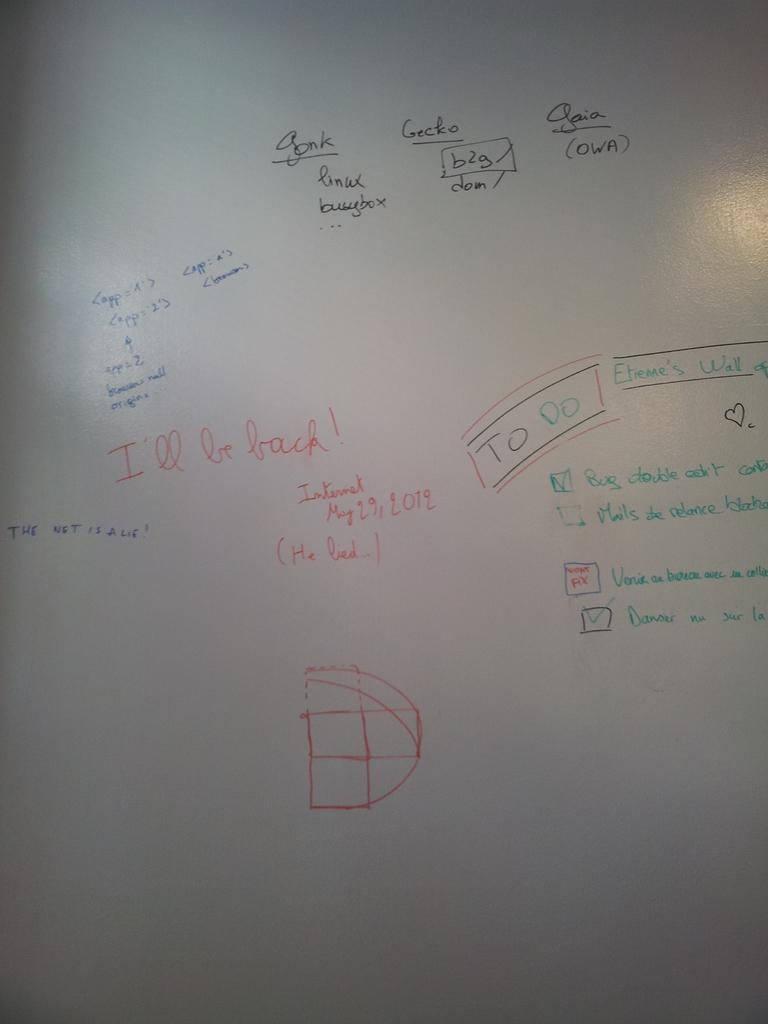<image>
Offer a succinct explanation of the picture presented. A board with formulas and a to do list written by etieme's. 